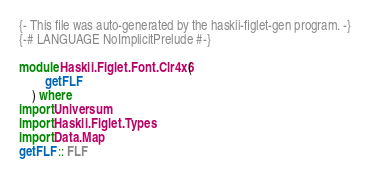<code> <loc_0><loc_0><loc_500><loc_500><_Haskell_>{- This file was auto-generated by the haskii-figlet-gen program. -}
{-# LANGUAGE NoImplicitPrelude #-}

module Haskii.Figlet.Font.Clr4x6 (
        getFLF
    ) where
import Universum
import Haskii.Figlet.Types
import Data.Map
getFLF :: FLF</code> 